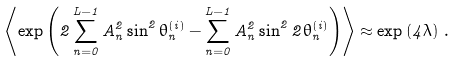Convert formula to latex. <formula><loc_0><loc_0><loc_500><loc_500>\left < \exp \left ( 2 \sum _ { n = 0 } ^ { L - 1 } A _ { n } ^ { 2 } \sin ^ { 2 } \theta _ { n } ^ { ( i ) } - \sum _ { n = 0 } ^ { L - 1 } A _ { n } ^ { 2 } \sin ^ { 2 } 2 \theta _ { n } ^ { ( i ) } \right ) \right > \approx \exp \left ( 4 \lambda \right ) \, .</formula> 